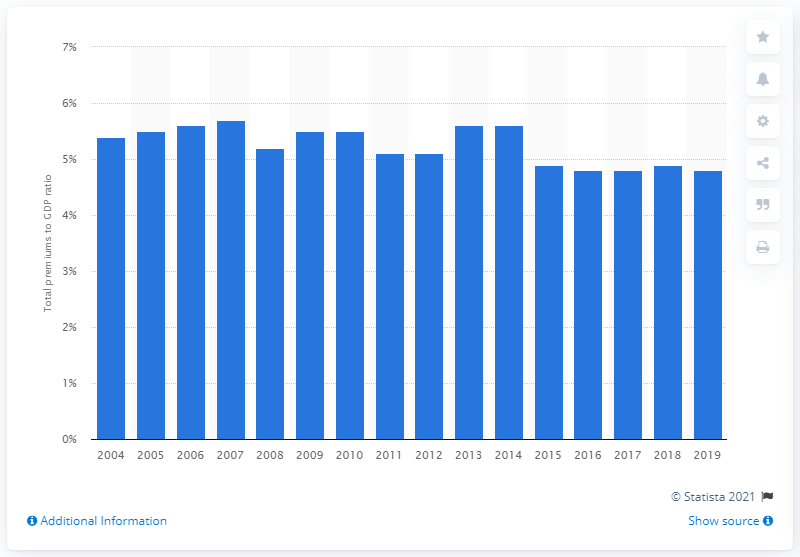Highlight a few significant elements in this photo. In 2019, the ratio of insurance premiums to GDP was 4.8%. 